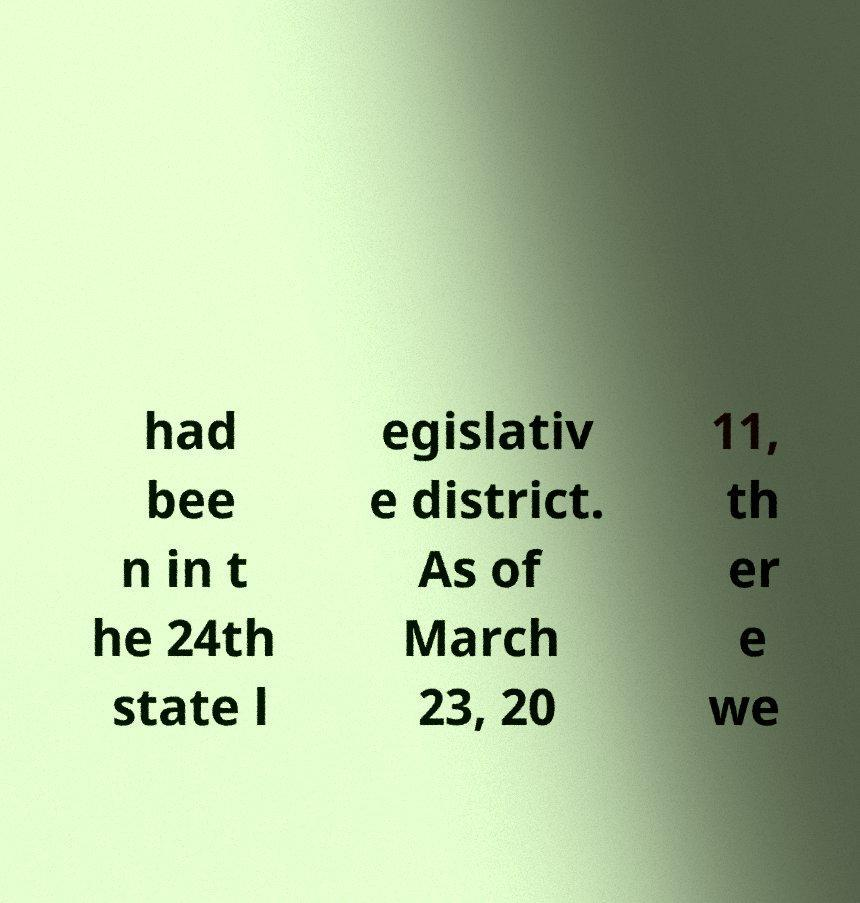Please read and relay the text visible in this image. What does it say? had bee n in t he 24th state l egislativ e district. As of March 23, 20 11, th er e we 